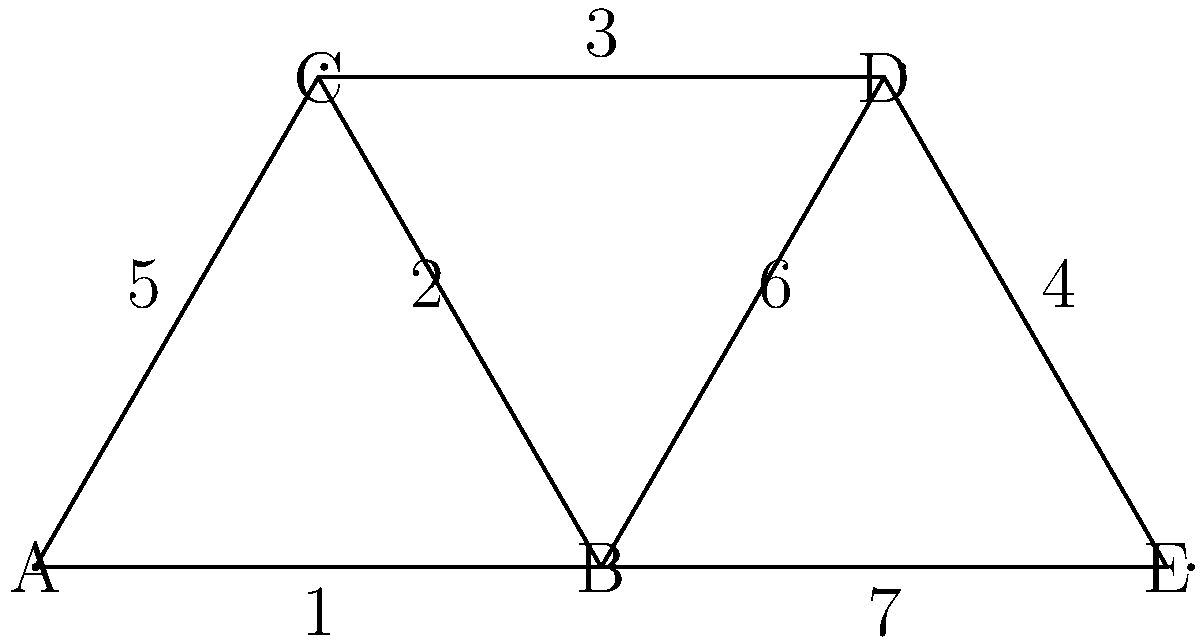In an AR scene, objects A, B, C, D, and E need to be rendered with different priorities to avoid visual conflicts. The edges in the graph represent potential conflicts between objects. Using graph coloring to assign rendering priorities, what is the minimum number of priority levels (colors) needed to ensure no two conflicting objects have the same priority? To solve this problem, we'll use graph coloring techniques:

1. Analyze the graph:
   - The graph has 5 nodes (A, B, C, D, E) representing AR objects.
   - Edges between nodes represent potential conflicts.

2. Apply the graph coloring algorithm:
   - Start with node A and assign it color 1.
   - Move to node B, which is connected to A. Assign it color 2.
   - For node C, it's connected to both A and B, so assign it color 3.
   - Node D is connected to B and C, but not A. We can use color 1 for D.
   - Node E is connected to B and D. We can use color 3 for E.

3. Count the number of colors used:
   - We used 3 distinct colors (priority levels) in this coloring.

4. Verify the coloring:
   - No two adjacent nodes (conflicting objects) have the same color.
   - This is a valid coloring that minimizes the number of colors used.

5. Consider alternatives:
   - There's no way to color this graph with fewer than 3 colors because of the triangle formed by nodes A, B, and C.

Therefore, the minimum number of priority levels (colors) needed is 3.
Answer: 3 priority levels 